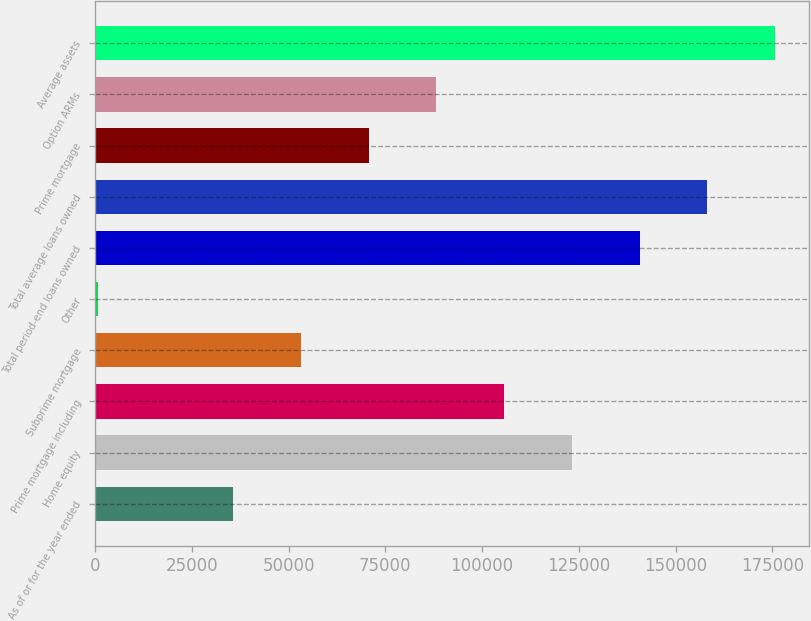Convert chart. <chart><loc_0><loc_0><loc_500><loc_500><bar_chart><fcel>As of or for the year ended<fcel>Home equity<fcel>Prime mortgage including<fcel>Subprime mortgage<fcel>Other<fcel>Total period-end loans owned<fcel>Total average loans owned<fcel>Prime mortgage<fcel>Option ARMs<fcel>Average assets<nl><fcel>35648.8<fcel>123188<fcel>105680<fcel>53156.7<fcel>633<fcel>140696<fcel>158204<fcel>70664.6<fcel>88172.5<fcel>175712<nl></chart> 